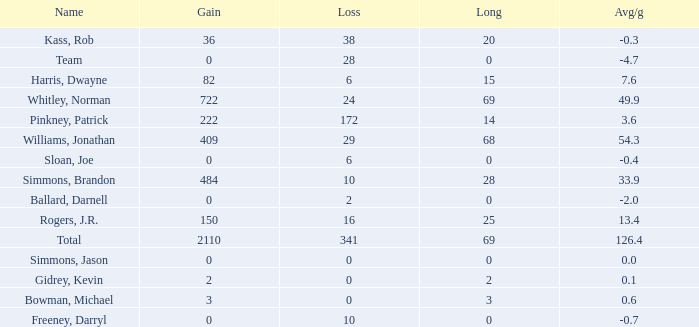What is the average Loss, when Avg/g is 0, and when Long is less than 0? None. 